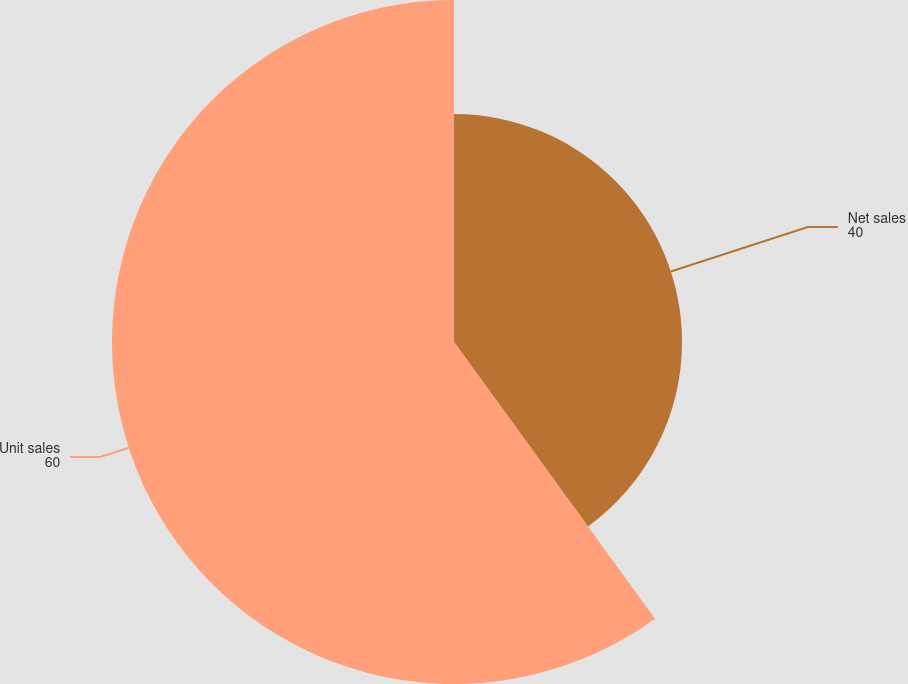<chart> <loc_0><loc_0><loc_500><loc_500><pie_chart><fcel>Net sales<fcel>Unit sales<nl><fcel>40.0%<fcel>60.0%<nl></chart> 